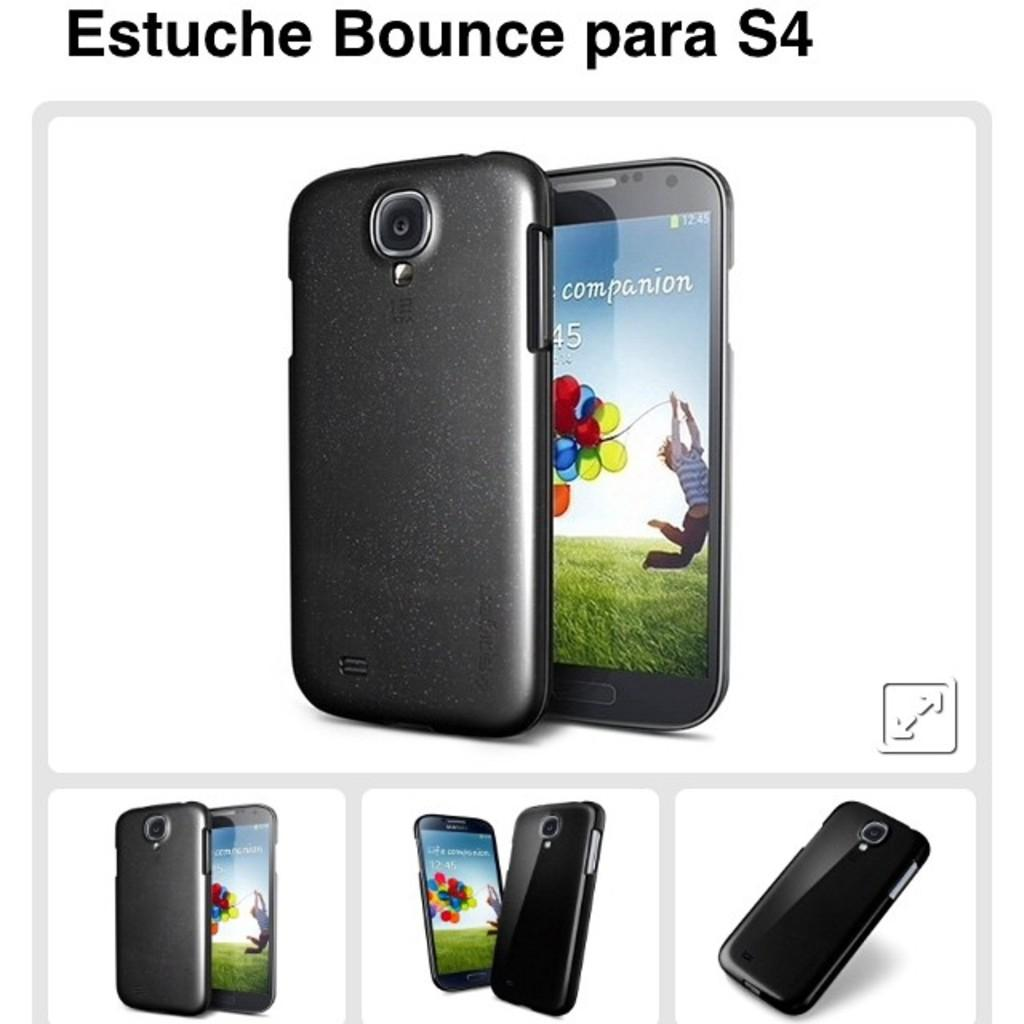Provide a one-sentence caption for the provided image. An S4 cell phone is shown in different positions. 